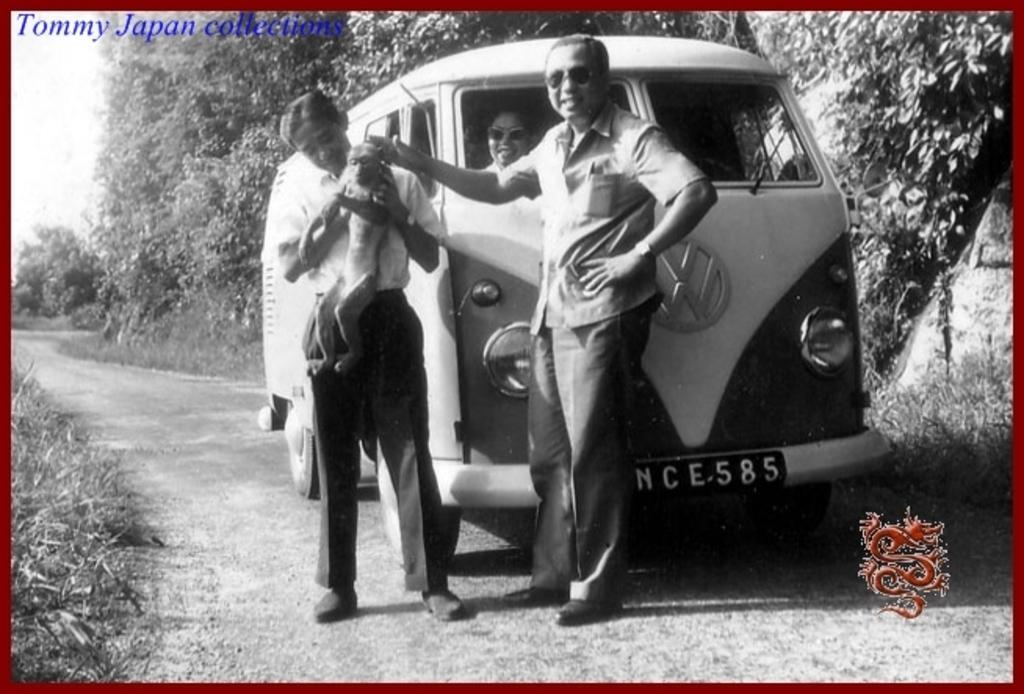Describe this image in one or two sentences. In the image two persons are standing and he is holding a monkey. Behind them there is a vehicle, in the vehicle a person is sitting and they are smiling. Behind the vehicle there are some trees. At the bottom of the image there is grass and road. 